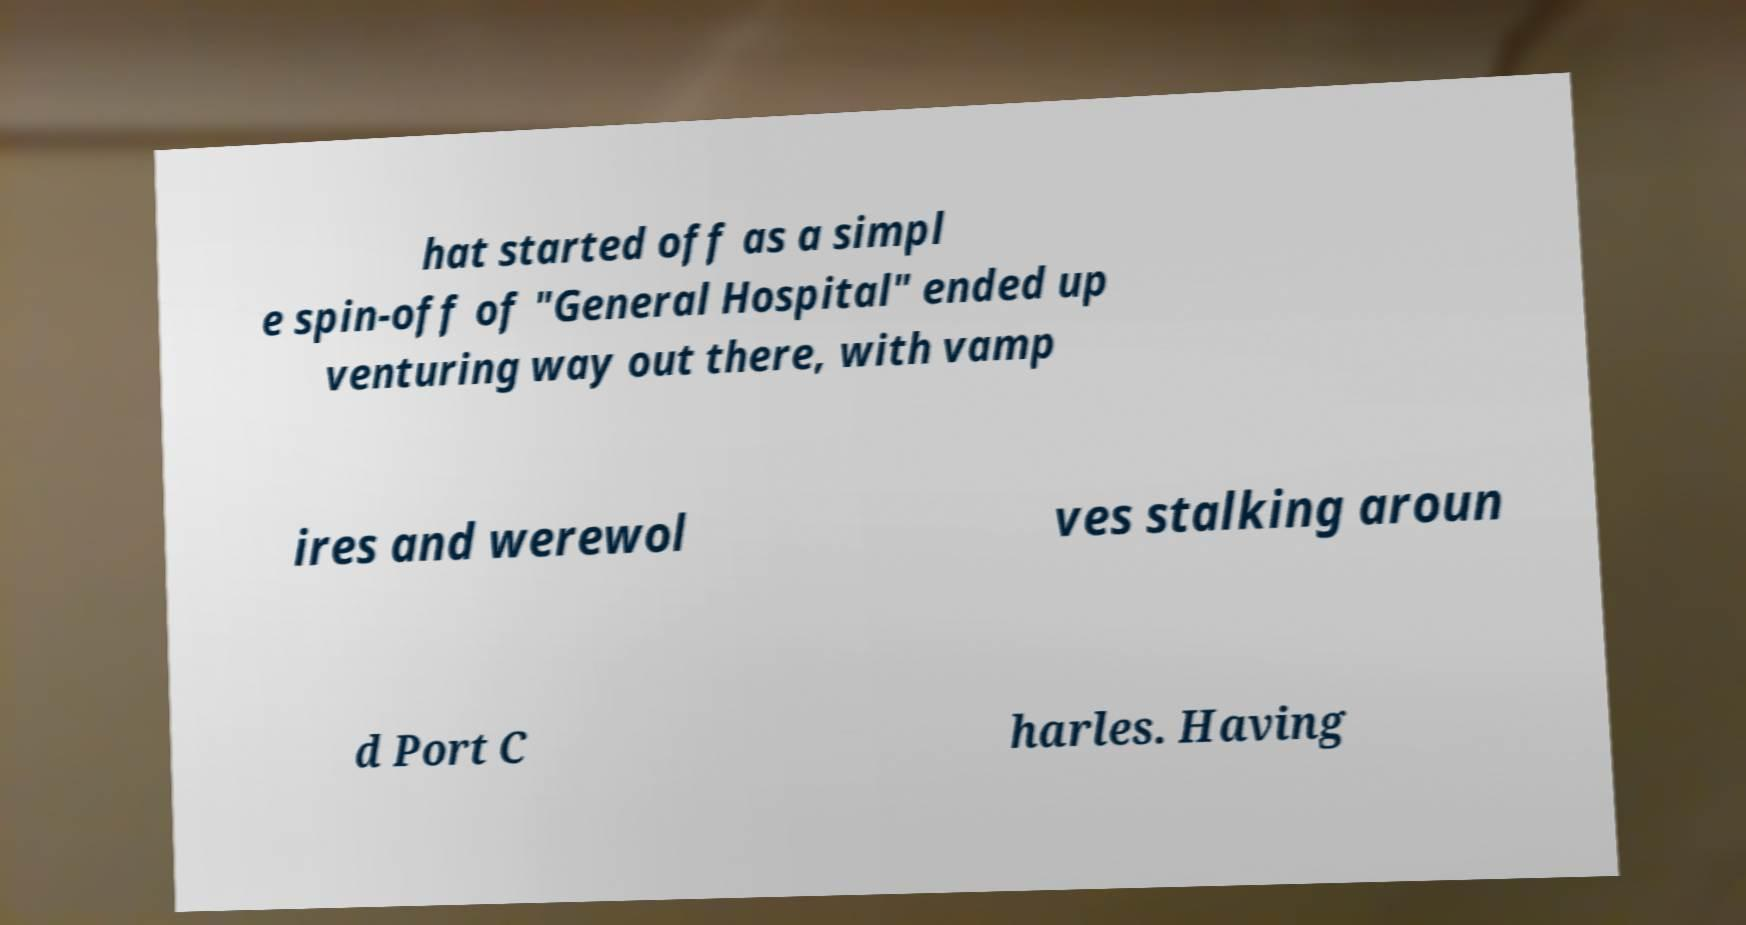Can you accurately transcribe the text from the provided image for me? hat started off as a simpl e spin-off of "General Hospital" ended up venturing way out there, with vamp ires and werewol ves stalking aroun d Port C harles. Having 